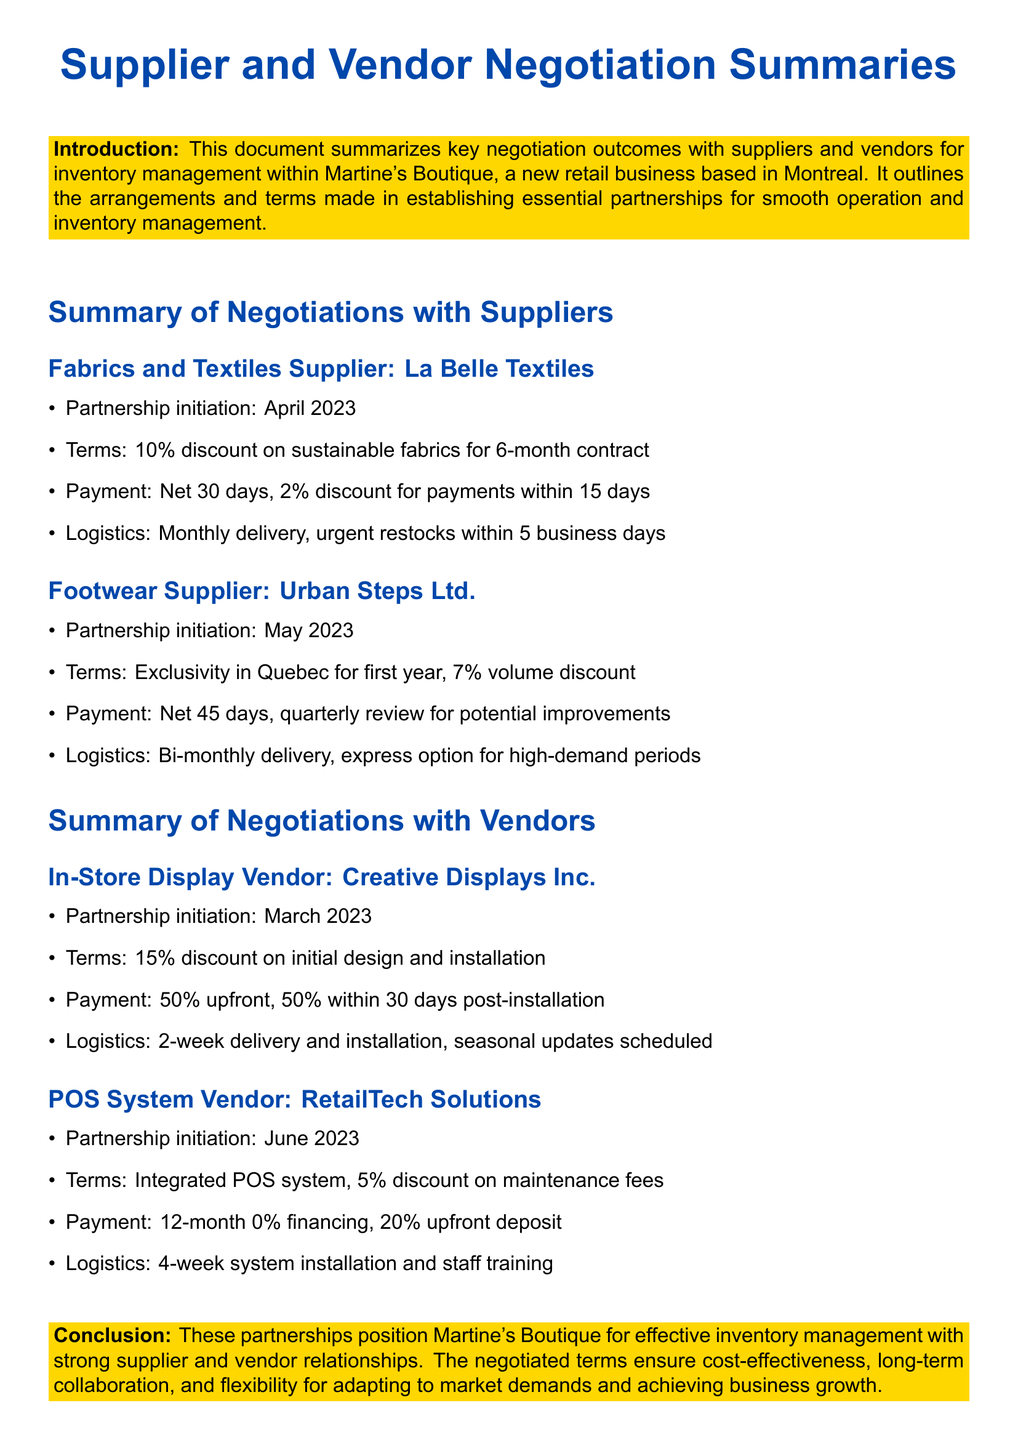What is the name of the fabrics supplier? The fabrics supplier mentioned in the document is La Belle Textiles.
Answer: La Belle Textiles When was the partnership with Urban Steps Ltd. initiated? The partnership with Urban Steps Ltd. was initiated in May 2023.
Answer: May 2023 What is the initial discount offered by Creative Displays Inc.? The initial discount offered by Creative Displays Inc. is 15%.
Answer: 15% How long is the payment term for the POS System Vendor? The payment term for the POS System Vendor is 12 months with 0% financing.
Answer: 12 months What percentage discount is offered on sustainable fabrics? A 10% discount is offered on sustainable fabrics.
Answer: 10% What is the logistics arrangement with La Belle Textiles? The logistics arrangement is monthly delivery, urgent restocks within 5 business days.
Answer: Monthly delivery, urgent restocks within 5 business days What type of discount does Urban Steps Ltd. offer? Urban Steps Ltd. offers a volume discount of 7%.
Answer: 7% What is required for the payment to Creative Displays Inc.? The payment requires 50% upfront and 50% within 30 days post-installation.
Answer: 50% upfront, 50% within 30 days What training is included in the logistics with RetailTech Solutions? The logistics with RetailTech Solutions includes staff training.
Answer: Staff training 